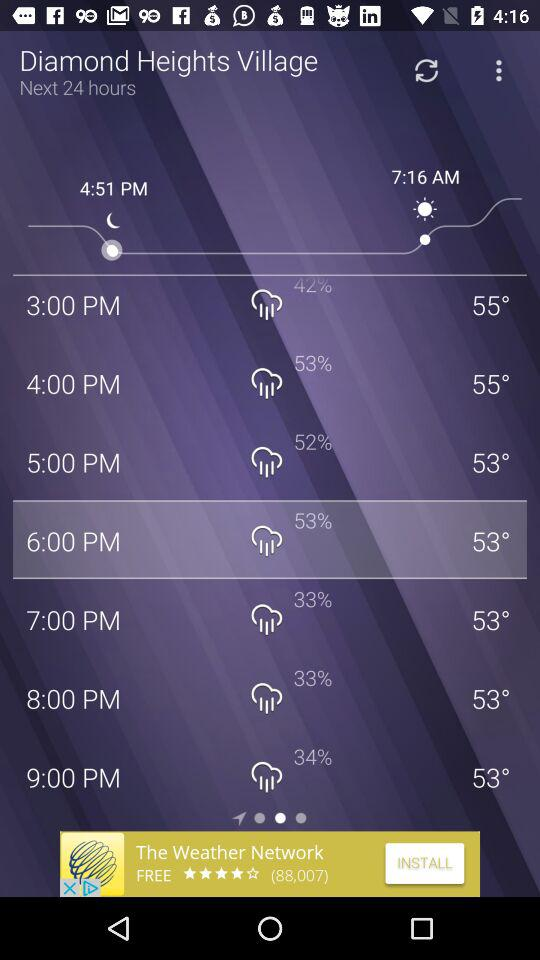For how many hours is the forecast? The forecast is for the next 24 hours. 